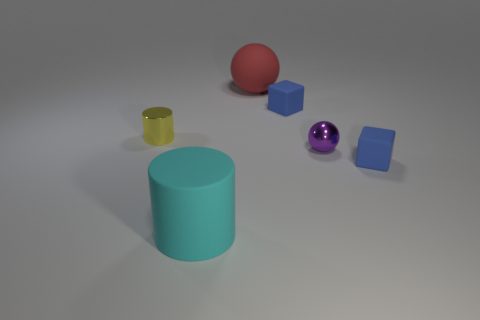Add 1 large red balls. How many objects exist? 7 Subtract all blocks. How many objects are left? 4 Subtract 1 cylinders. How many cylinders are left? 1 Add 2 large purple rubber cylinders. How many large purple rubber cylinders exist? 2 Subtract 0 gray cylinders. How many objects are left? 6 Subtract all large rubber cylinders. Subtract all big cyan matte objects. How many objects are left? 4 Add 6 small yellow metallic objects. How many small yellow metallic objects are left? 7 